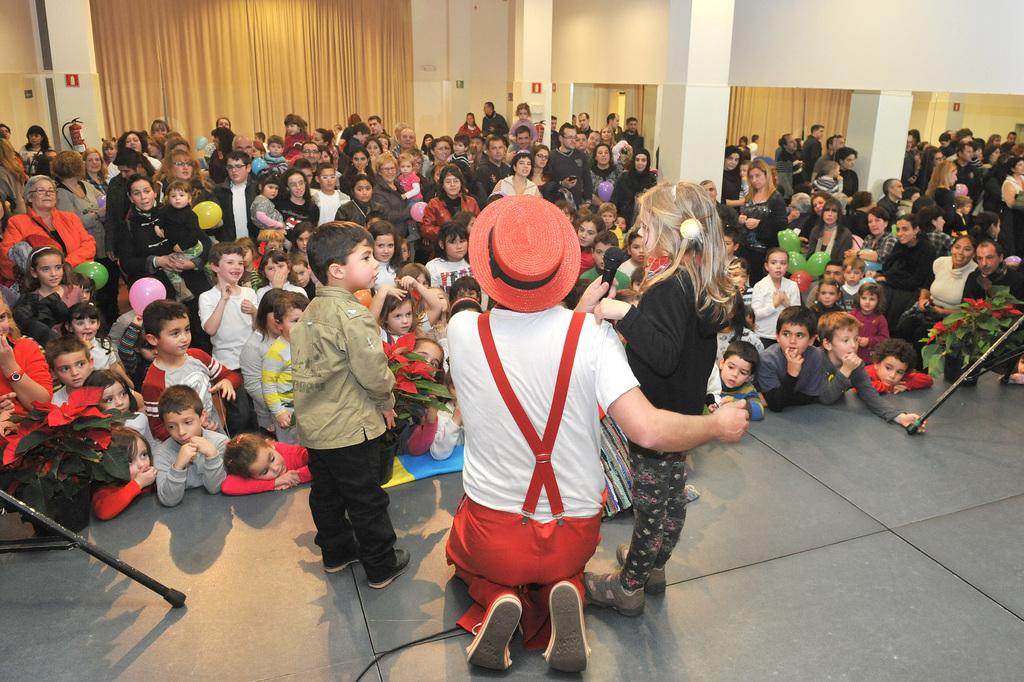What is the person in the image wearing on their head? There is a person with a hat in the image. How many people are present in the image? There are multiple people standing and sitting in the image. What type of vegetation is present in the image? There are plants in the image. What medical equipment can be seen in the image? There is an oxygen cylinder in the image. What type of window treatment is present in the image? There are curtains in the image. What architectural feature is present in the image? There are pillars in the image. What type of creature is sitting on the person's shoulder in the image? There is no creature present on anyone's shoulder in the image. How many ducks are visible in the image? There are no ducks present in the image. 